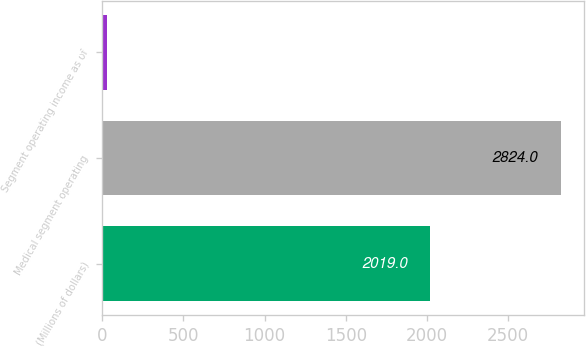Convert chart. <chart><loc_0><loc_0><loc_500><loc_500><bar_chart><fcel>(Millions of dollars)<fcel>Medical segment operating<fcel>Segment operating income as of<nl><fcel>2019<fcel>2824<fcel>31.2<nl></chart> 